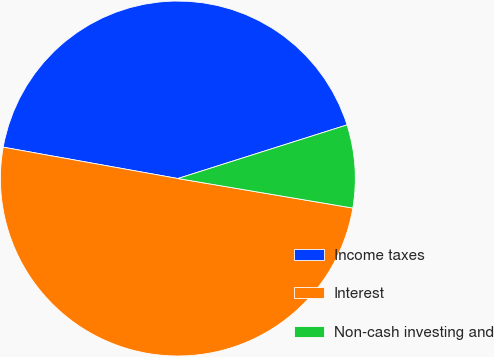Convert chart to OTSL. <chart><loc_0><loc_0><loc_500><loc_500><pie_chart><fcel>Income taxes<fcel>Interest<fcel>Non-cash investing and<nl><fcel>42.29%<fcel>50.17%<fcel>7.55%<nl></chart> 